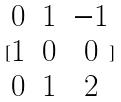Convert formula to latex. <formula><loc_0><loc_0><loc_500><loc_500>[ \begin{matrix} 0 & 1 & - 1 \\ 1 & 0 & 0 \\ 0 & 1 & 2 \end{matrix} ]</formula> 